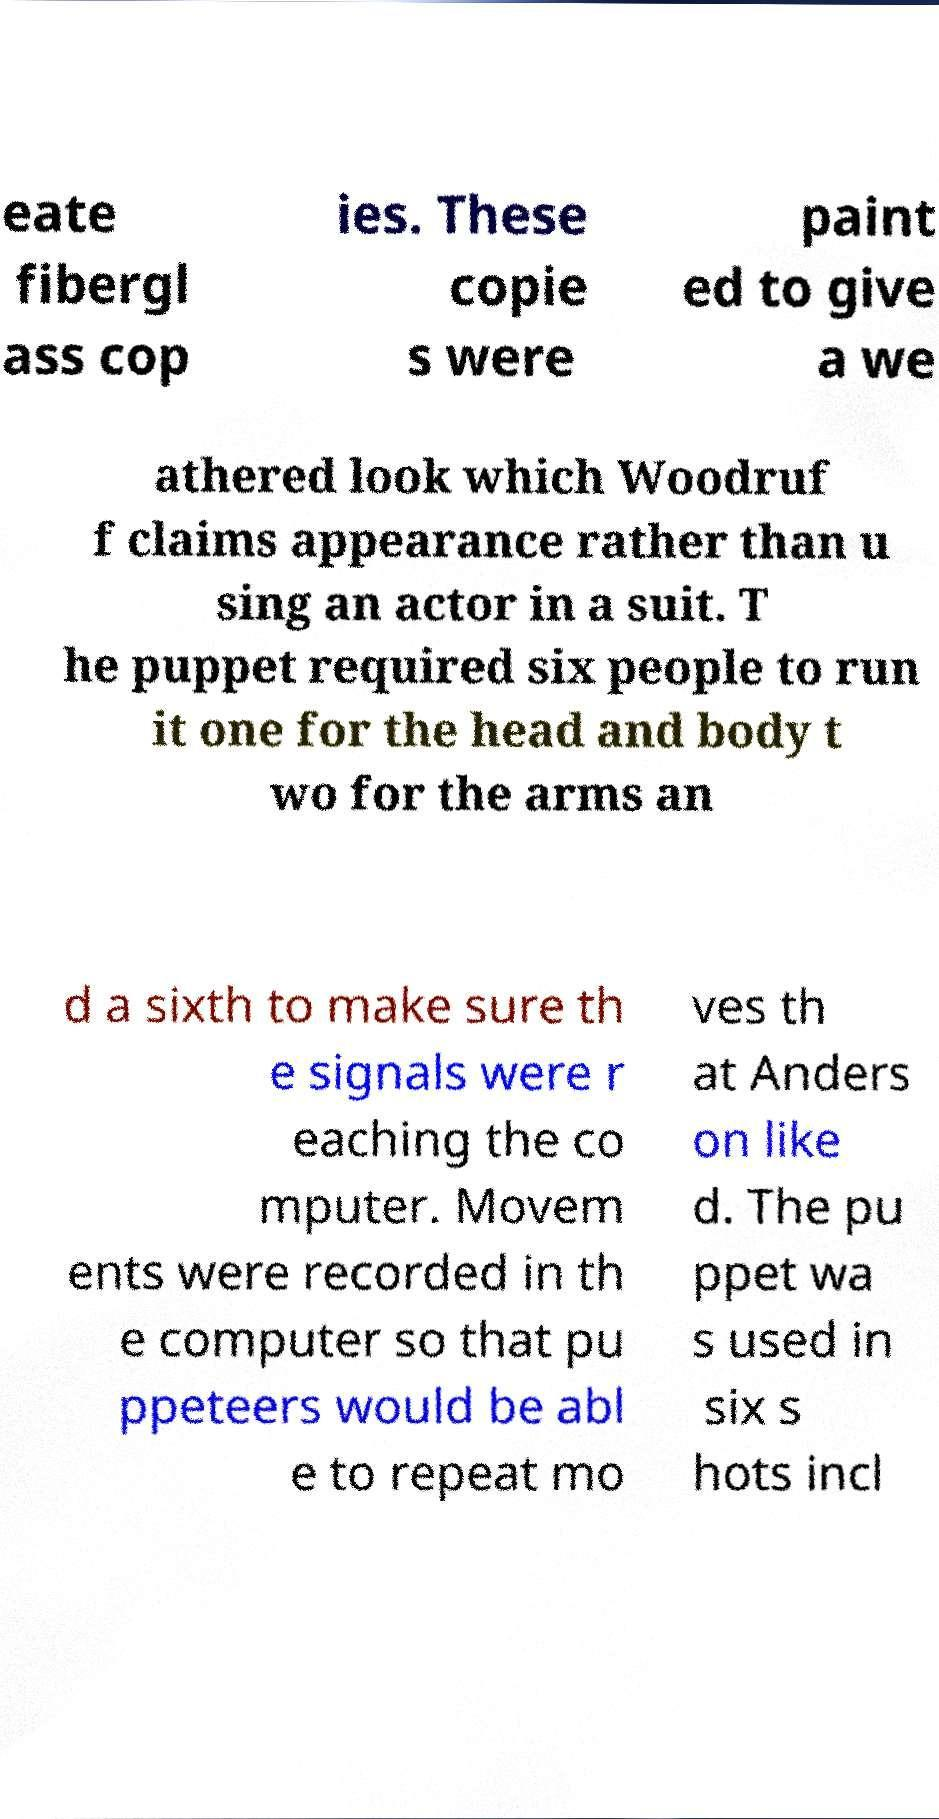Could you assist in decoding the text presented in this image and type it out clearly? eate fibergl ass cop ies. These copie s were paint ed to give a we athered look which Woodruf f claims appearance rather than u sing an actor in a suit. T he puppet required six people to run it one for the head and body t wo for the arms an d a sixth to make sure th e signals were r eaching the co mputer. Movem ents were recorded in th e computer so that pu ppeteers would be abl e to repeat mo ves th at Anders on like d. The pu ppet wa s used in six s hots incl 